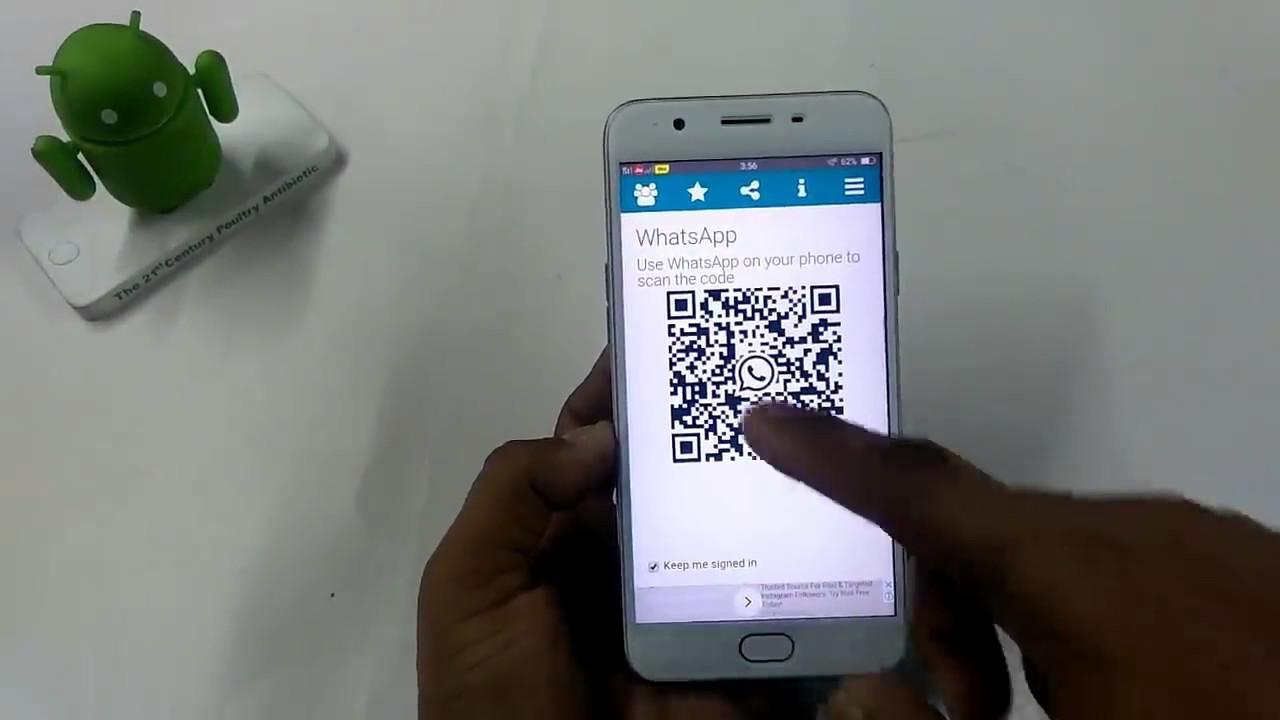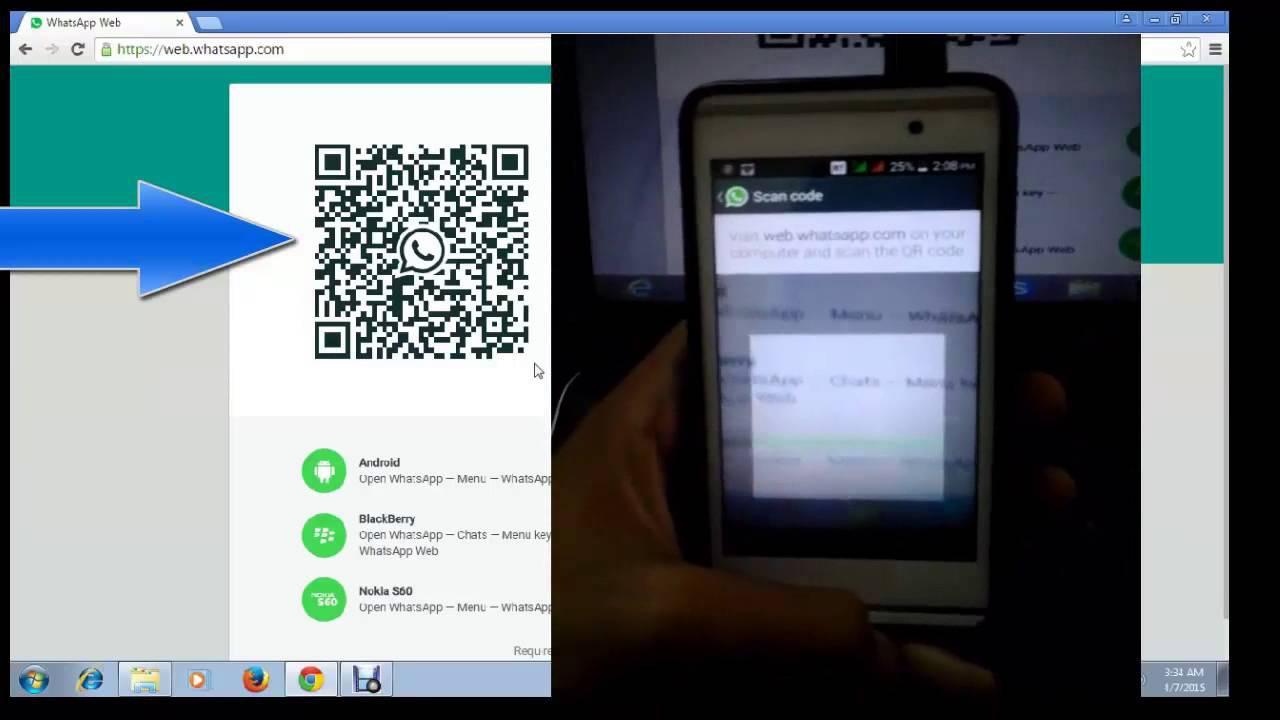The first image is the image on the left, the second image is the image on the right. Examine the images to the left and right. Is the description "There are three smartphones." accurate? Answer yes or no. No. The first image is the image on the left, the second image is the image on the right. Given the left and right images, does the statement "All of the phones have a QR Code on the screen." hold true? Answer yes or no. No. 